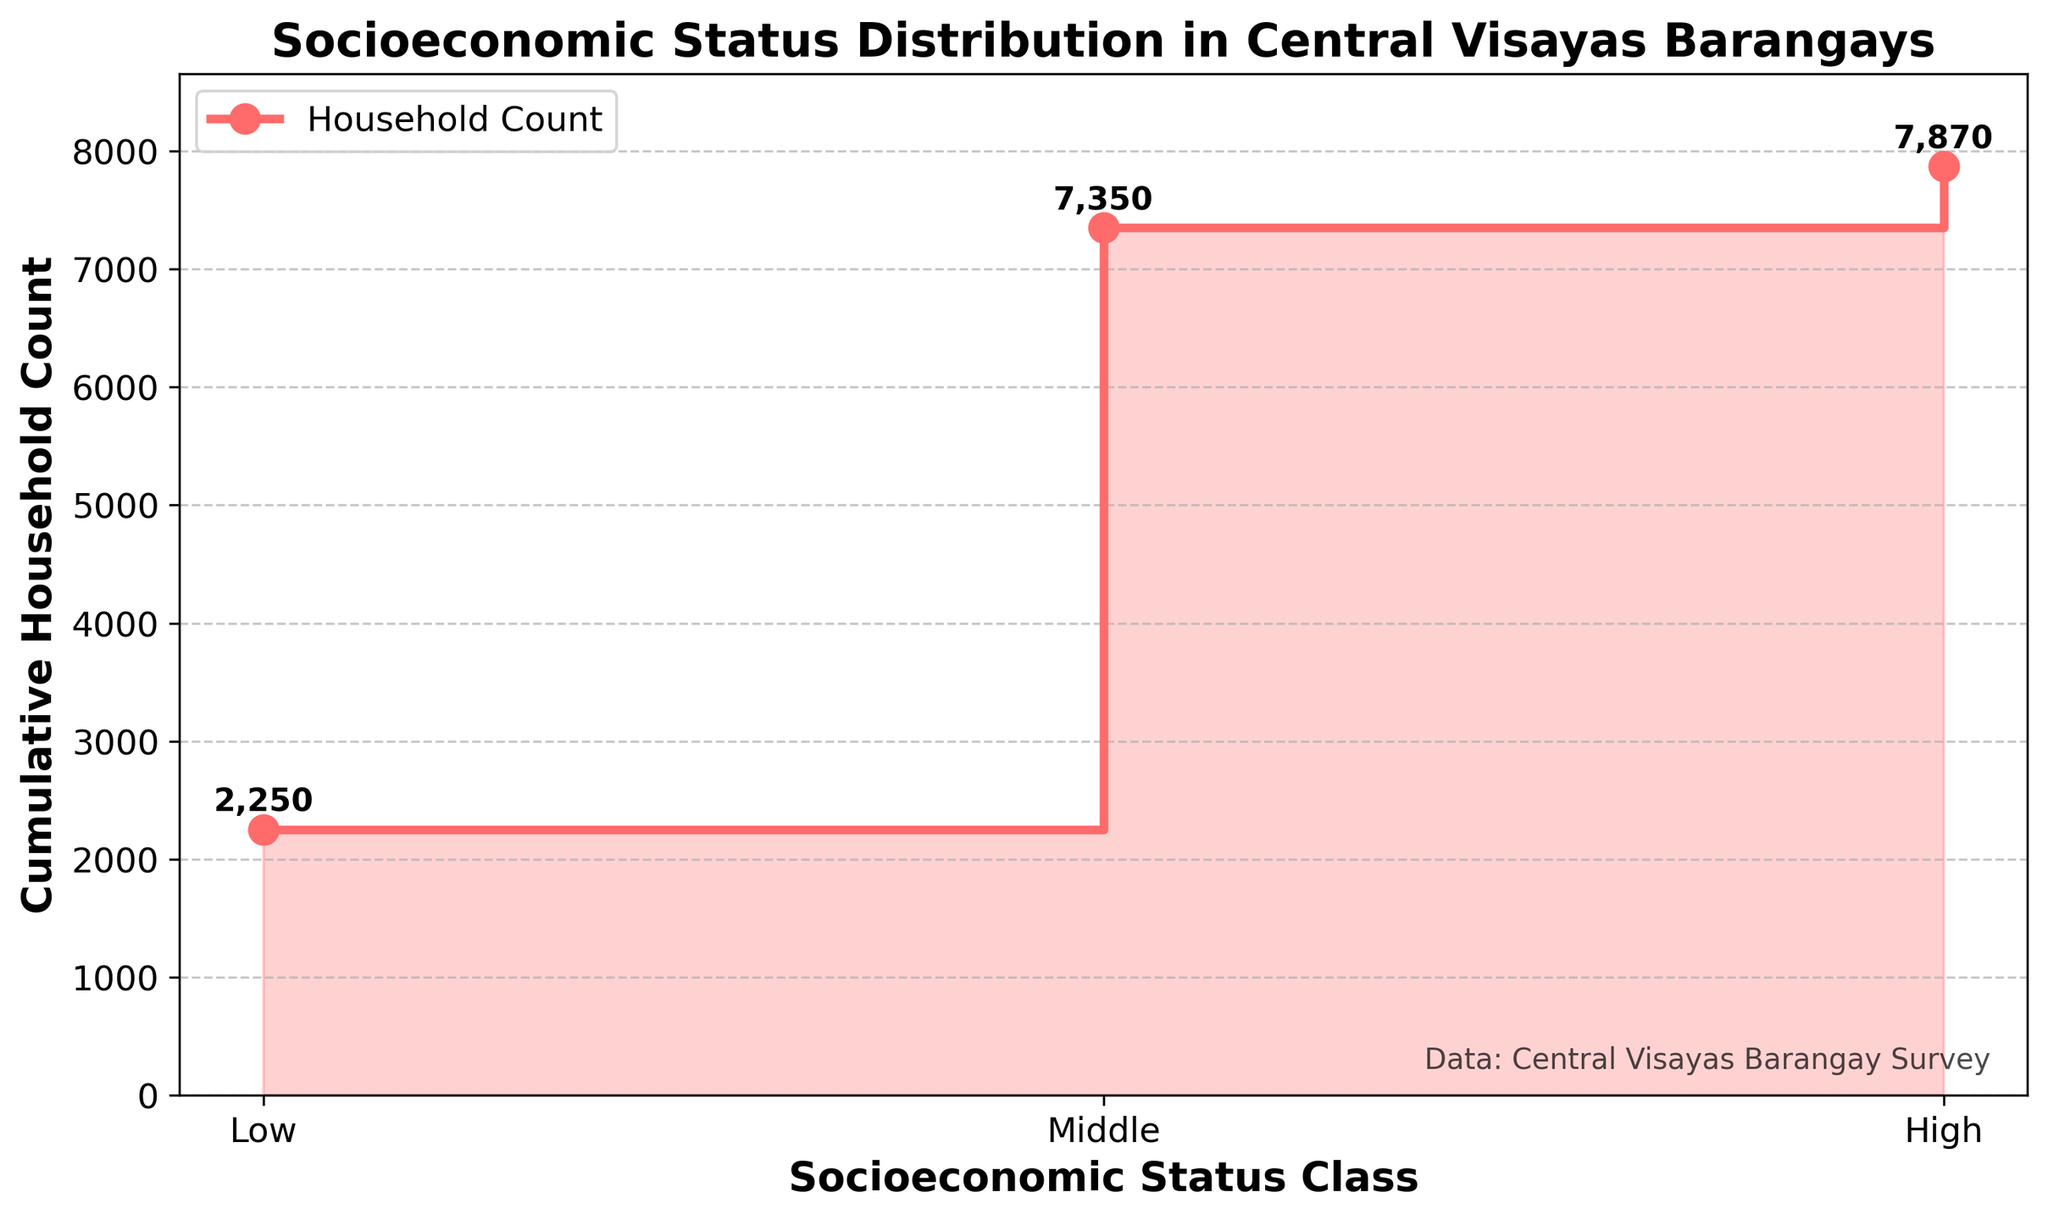What are the socioeconomic status classes mentioned in the plot? The x-axis shows three different classes representing socioeconomic status: Low, Middle, and High.
Answer: Low, Middle, High What is the total cumulative household count for all barangays? The top value on the y-axis at the end of the stair plot shows the cumulative household count, which is the sum of all households.
Answer: 9,670 Which socioeconomic status class has the highest cumulative household count? By examining the highest point on the plot, we see that the Middle class has the highest cumulative household count before it slopes to the next class.
Answer: Middle How many households are in barangays classified as Low socioeconomic status? Observing the plot, the first step or segment represents the lowest socioeconomic class. The cumulative value here is the household count for the Low class.
Answer: 2,250 What is the difference in cumulative household count between Middle and High socioeconomic status classes? The cumulative household count for the Middle class is shown before the step towards the High class, and for High class is the final value. Subtract the Middle class count from the High class count to find the difference.
Answer: 6,300 − 9,670 = −3,370 How does the household count of the Middle class compare to the combined count of Low and High classes? Summing counts from Low and High classes and comparing it to Middle class, the plot shows this relationship. Low + High = 2,250 + 670. Middle class is 6,300, which is higher than 2,920.
Answer: Middle is higher What household count does the cumulative plot start with for the Low socioeconomic status? The starting point of the cumulative stair plot represents the total household count for the Low socioeconomic class, which is the first point.
Answer: 2,250 What is the cumulative increase in household count from Low to Middle socioeconomic status? The difference between the cumulative count value for Middle class and Low class on the graph shows the increase.
Answer: 6,300 − 2,250 = 4,050 At which socioeconomic class does the cumulative household count exceed 5,000? By looking at the cumulative values along the x-axis for different classes, we see it exceeds 5,000 during the transition to Middle class.
Answer: Middle Examine the visual trend represented in the stair plot. Is the cumulative household count trend increasing steadily or does it change abruptly at any point? The visual trend of the plot has a steady increase from Low to Middle and High classes showing consistent increments without abrupt changes.
Answer: Steady increase 